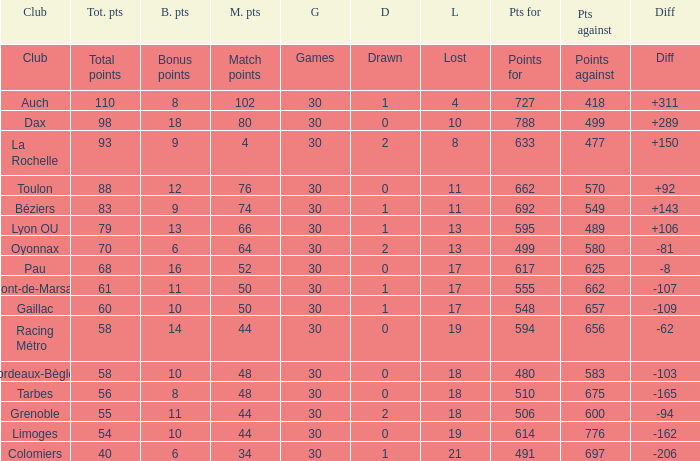Could you help me parse every detail presented in this table? {'header': ['Club', 'Tot. pts', 'B. pts', 'M. pts', 'G', 'D', 'L', 'Pts for', 'Pts against', 'Diff'], 'rows': [['Club', 'Total points', 'Bonus points', 'Match points', 'Games', 'Drawn', 'Lost', 'Points for', 'Points against', 'Diff'], ['Auch', '110', '8', '102', '30', '1', '4', '727', '418', '+311'], ['Dax', '98', '18', '80', '30', '0', '10', '788', '499', '+289'], ['La Rochelle', '93', '9', '4', '30', '2', '8', '633', '477', '+150'], ['Toulon', '88', '12', '76', '30', '0', '11', '662', '570', '+92'], ['Béziers', '83', '9', '74', '30', '1', '11', '692', '549', '+143'], ['Lyon OU', '79', '13', '66', '30', '1', '13', '595', '489', '+106'], ['Oyonnax', '70', '6', '64', '30', '2', '13', '499', '580', '-81'], ['Pau', '68', '16', '52', '30', '0', '17', '617', '625', '-8'], ['Mont-de-Marsan', '61', '11', '50', '30', '1', '17', '555', '662', '-107'], ['Gaillac', '60', '10', '50', '30', '1', '17', '548', '657', '-109'], ['Racing Métro', '58', '14', '44', '30', '0', '19', '594', '656', '-62'], ['Bordeaux-Bègles', '58', '10', '48', '30', '0', '18', '480', '583', '-103'], ['Tarbes', '56', '8', '48', '30', '0', '18', '510', '675', '-165'], ['Grenoble', '55', '11', '44', '30', '2', '18', '506', '600', '-94'], ['Limoges', '54', '10', '44', '30', '0', '19', '614', '776', '-162'], ['Colomiers', '40', '6', '34', '30', '1', '21', '491', '697', '-206']]} What is the amount of match points for a club that lost 18 and has 11 bonus points? 44.0. 